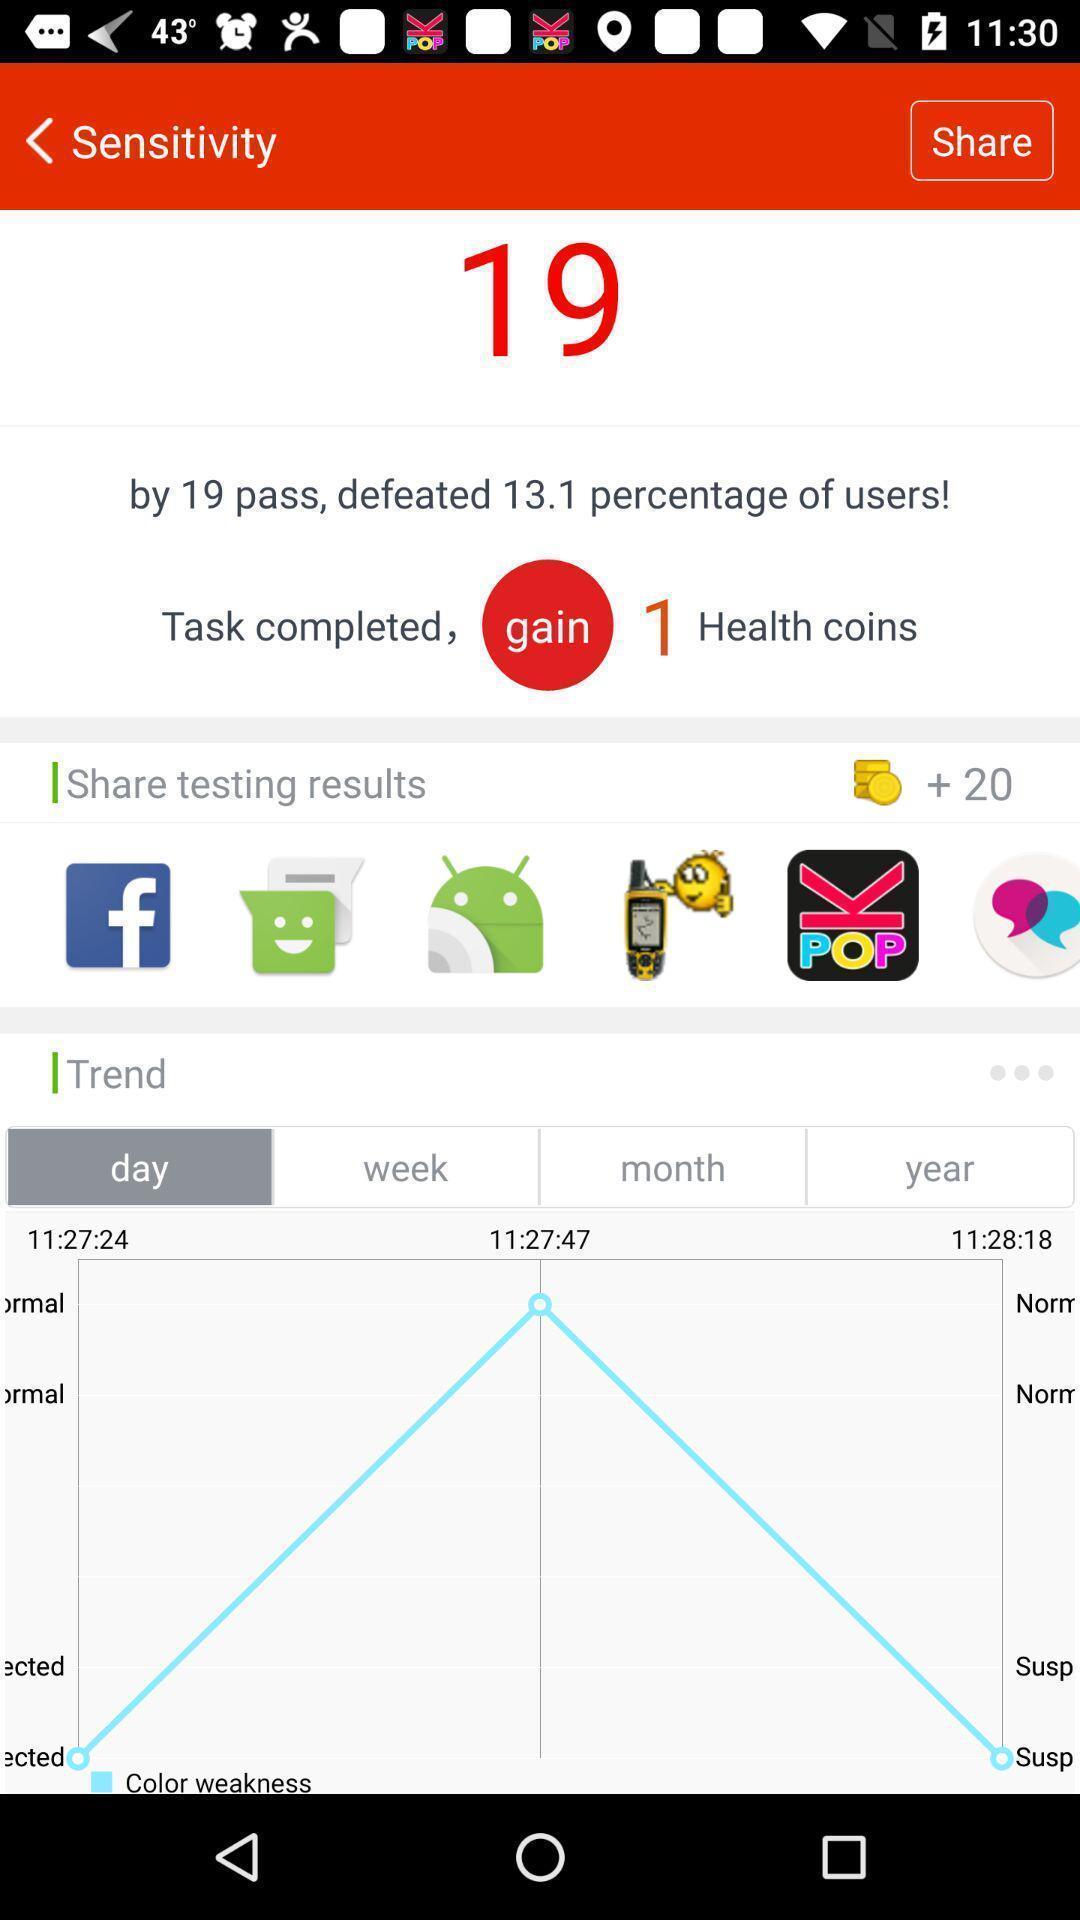Summarize the information in this screenshot. Screen displaying multiple social application icons and statistics information. 